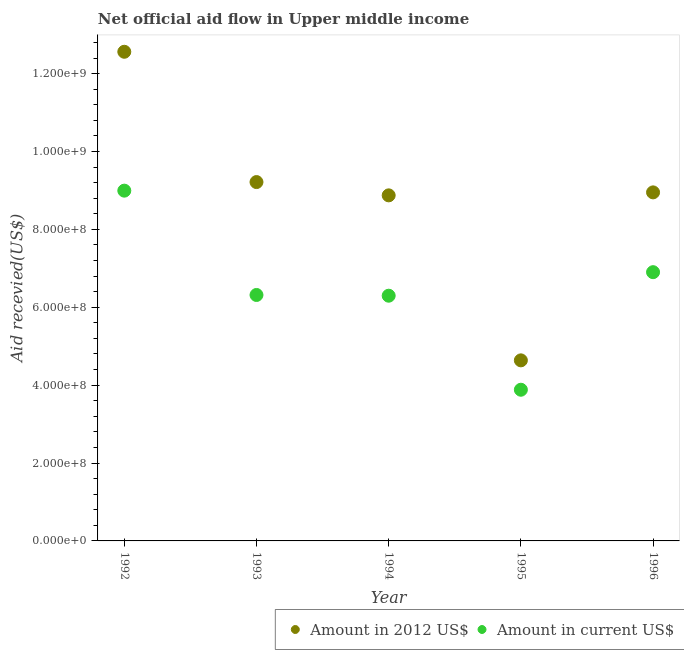What is the amount of aid received(expressed in 2012 us$) in 1995?
Offer a terse response. 4.64e+08. Across all years, what is the maximum amount of aid received(expressed in 2012 us$)?
Offer a very short reply. 1.26e+09. Across all years, what is the minimum amount of aid received(expressed in 2012 us$)?
Make the answer very short. 4.64e+08. In which year was the amount of aid received(expressed in 2012 us$) maximum?
Provide a short and direct response. 1992. In which year was the amount of aid received(expressed in us$) minimum?
Your answer should be compact. 1995. What is the total amount of aid received(expressed in us$) in the graph?
Ensure brevity in your answer.  3.24e+09. What is the difference between the amount of aid received(expressed in us$) in 1993 and that in 1995?
Keep it short and to the point. 2.43e+08. What is the difference between the amount of aid received(expressed in us$) in 1994 and the amount of aid received(expressed in 2012 us$) in 1996?
Provide a succinct answer. -2.65e+08. What is the average amount of aid received(expressed in 2012 us$) per year?
Your answer should be very brief. 8.85e+08. In the year 1996, what is the difference between the amount of aid received(expressed in 2012 us$) and amount of aid received(expressed in us$)?
Offer a very short reply. 2.05e+08. In how many years, is the amount of aid received(expressed in us$) greater than 880000000 US$?
Offer a very short reply. 1. What is the ratio of the amount of aid received(expressed in 2012 us$) in 1993 to that in 1995?
Make the answer very short. 1.99. Is the amount of aid received(expressed in us$) in 1994 less than that in 1995?
Keep it short and to the point. No. Is the difference between the amount of aid received(expressed in 2012 us$) in 1992 and 1994 greater than the difference between the amount of aid received(expressed in us$) in 1992 and 1994?
Offer a terse response. Yes. What is the difference between the highest and the second highest amount of aid received(expressed in 2012 us$)?
Give a very brief answer. 3.35e+08. What is the difference between the highest and the lowest amount of aid received(expressed in us$)?
Give a very brief answer. 5.11e+08. Is the sum of the amount of aid received(expressed in us$) in 1992 and 1993 greater than the maximum amount of aid received(expressed in 2012 us$) across all years?
Offer a very short reply. Yes. How many years are there in the graph?
Offer a very short reply. 5. Does the graph contain any zero values?
Offer a very short reply. No. Where does the legend appear in the graph?
Ensure brevity in your answer.  Bottom right. How many legend labels are there?
Keep it short and to the point. 2. How are the legend labels stacked?
Provide a succinct answer. Horizontal. What is the title of the graph?
Offer a very short reply. Net official aid flow in Upper middle income. Does "Automatic Teller Machines" appear as one of the legend labels in the graph?
Offer a terse response. No. What is the label or title of the Y-axis?
Ensure brevity in your answer.  Aid recevied(US$). What is the Aid recevied(US$) in Amount in 2012 US$ in 1992?
Provide a succinct answer. 1.26e+09. What is the Aid recevied(US$) of Amount in current US$ in 1992?
Provide a succinct answer. 8.99e+08. What is the Aid recevied(US$) in Amount in 2012 US$ in 1993?
Your answer should be very brief. 9.21e+08. What is the Aid recevied(US$) of Amount in current US$ in 1993?
Make the answer very short. 6.32e+08. What is the Aid recevied(US$) of Amount in 2012 US$ in 1994?
Your answer should be very brief. 8.87e+08. What is the Aid recevied(US$) of Amount in current US$ in 1994?
Make the answer very short. 6.30e+08. What is the Aid recevied(US$) in Amount in 2012 US$ in 1995?
Your answer should be compact. 4.64e+08. What is the Aid recevied(US$) of Amount in current US$ in 1995?
Keep it short and to the point. 3.88e+08. What is the Aid recevied(US$) in Amount in 2012 US$ in 1996?
Provide a short and direct response. 8.95e+08. What is the Aid recevied(US$) in Amount in current US$ in 1996?
Your answer should be very brief. 6.90e+08. Across all years, what is the maximum Aid recevied(US$) in Amount in 2012 US$?
Offer a very short reply. 1.26e+09. Across all years, what is the maximum Aid recevied(US$) in Amount in current US$?
Your response must be concise. 8.99e+08. Across all years, what is the minimum Aid recevied(US$) of Amount in 2012 US$?
Your answer should be very brief. 4.64e+08. Across all years, what is the minimum Aid recevied(US$) of Amount in current US$?
Make the answer very short. 3.88e+08. What is the total Aid recevied(US$) in Amount in 2012 US$ in the graph?
Make the answer very short. 4.42e+09. What is the total Aid recevied(US$) of Amount in current US$ in the graph?
Keep it short and to the point. 3.24e+09. What is the difference between the Aid recevied(US$) in Amount in 2012 US$ in 1992 and that in 1993?
Give a very brief answer. 3.35e+08. What is the difference between the Aid recevied(US$) in Amount in current US$ in 1992 and that in 1993?
Your answer should be very brief. 2.68e+08. What is the difference between the Aid recevied(US$) of Amount in 2012 US$ in 1992 and that in 1994?
Offer a very short reply. 3.69e+08. What is the difference between the Aid recevied(US$) in Amount in current US$ in 1992 and that in 1994?
Your answer should be very brief. 2.70e+08. What is the difference between the Aid recevied(US$) in Amount in 2012 US$ in 1992 and that in 1995?
Give a very brief answer. 7.92e+08. What is the difference between the Aid recevied(US$) in Amount in current US$ in 1992 and that in 1995?
Provide a short and direct response. 5.11e+08. What is the difference between the Aid recevied(US$) of Amount in 2012 US$ in 1992 and that in 1996?
Offer a terse response. 3.61e+08. What is the difference between the Aid recevied(US$) of Amount in current US$ in 1992 and that in 1996?
Keep it short and to the point. 2.09e+08. What is the difference between the Aid recevied(US$) of Amount in 2012 US$ in 1993 and that in 1994?
Give a very brief answer. 3.41e+07. What is the difference between the Aid recevied(US$) of Amount in current US$ in 1993 and that in 1994?
Your answer should be very brief. 1.90e+06. What is the difference between the Aid recevied(US$) in Amount in 2012 US$ in 1993 and that in 1995?
Keep it short and to the point. 4.58e+08. What is the difference between the Aid recevied(US$) of Amount in current US$ in 1993 and that in 1995?
Your response must be concise. 2.43e+08. What is the difference between the Aid recevied(US$) of Amount in 2012 US$ in 1993 and that in 1996?
Your response must be concise. 2.65e+07. What is the difference between the Aid recevied(US$) of Amount in current US$ in 1993 and that in 1996?
Offer a very short reply. -5.85e+07. What is the difference between the Aid recevied(US$) in Amount in 2012 US$ in 1994 and that in 1995?
Provide a short and direct response. 4.24e+08. What is the difference between the Aid recevied(US$) of Amount in current US$ in 1994 and that in 1995?
Offer a terse response. 2.41e+08. What is the difference between the Aid recevied(US$) in Amount in 2012 US$ in 1994 and that in 1996?
Make the answer very short. -7.65e+06. What is the difference between the Aid recevied(US$) in Amount in current US$ in 1994 and that in 1996?
Your response must be concise. -6.04e+07. What is the difference between the Aid recevied(US$) of Amount in 2012 US$ in 1995 and that in 1996?
Give a very brief answer. -4.31e+08. What is the difference between the Aid recevied(US$) of Amount in current US$ in 1995 and that in 1996?
Keep it short and to the point. -3.02e+08. What is the difference between the Aid recevied(US$) in Amount in 2012 US$ in 1992 and the Aid recevied(US$) in Amount in current US$ in 1993?
Offer a terse response. 6.24e+08. What is the difference between the Aid recevied(US$) of Amount in 2012 US$ in 1992 and the Aid recevied(US$) of Amount in current US$ in 1994?
Your answer should be compact. 6.26e+08. What is the difference between the Aid recevied(US$) of Amount in 2012 US$ in 1992 and the Aid recevied(US$) of Amount in current US$ in 1995?
Offer a terse response. 8.68e+08. What is the difference between the Aid recevied(US$) in Amount in 2012 US$ in 1992 and the Aid recevied(US$) in Amount in current US$ in 1996?
Offer a terse response. 5.66e+08. What is the difference between the Aid recevied(US$) of Amount in 2012 US$ in 1993 and the Aid recevied(US$) of Amount in current US$ in 1994?
Keep it short and to the point. 2.92e+08. What is the difference between the Aid recevied(US$) in Amount in 2012 US$ in 1993 and the Aid recevied(US$) in Amount in current US$ in 1995?
Your response must be concise. 5.33e+08. What is the difference between the Aid recevied(US$) of Amount in 2012 US$ in 1993 and the Aid recevied(US$) of Amount in current US$ in 1996?
Your response must be concise. 2.31e+08. What is the difference between the Aid recevied(US$) of Amount in 2012 US$ in 1994 and the Aid recevied(US$) of Amount in current US$ in 1995?
Offer a very short reply. 4.99e+08. What is the difference between the Aid recevied(US$) of Amount in 2012 US$ in 1994 and the Aid recevied(US$) of Amount in current US$ in 1996?
Offer a very short reply. 1.97e+08. What is the difference between the Aid recevied(US$) in Amount in 2012 US$ in 1995 and the Aid recevied(US$) in Amount in current US$ in 1996?
Keep it short and to the point. -2.26e+08. What is the average Aid recevied(US$) in Amount in 2012 US$ per year?
Offer a very short reply. 8.85e+08. What is the average Aid recevied(US$) of Amount in current US$ per year?
Provide a succinct answer. 6.48e+08. In the year 1992, what is the difference between the Aid recevied(US$) in Amount in 2012 US$ and Aid recevied(US$) in Amount in current US$?
Ensure brevity in your answer.  3.57e+08. In the year 1993, what is the difference between the Aid recevied(US$) in Amount in 2012 US$ and Aid recevied(US$) in Amount in current US$?
Make the answer very short. 2.90e+08. In the year 1994, what is the difference between the Aid recevied(US$) of Amount in 2012 US$ and Aid recevied(US$) of Amount in current US$?
Your answer should be compact. 2.58e+08. In the year 1995, what is the difference between the Aid recevied(US$) in Amount in 2012 US$ and Aid recevied(US$) in Amount in current US$?
Your answer should be very brief. 7.54e+07. In the year 1996, what is the difference between the Aid recevied(US$) of Amount in 2012 US$ and Aid recevied(US$) of Amount in current US$?
Your answer should be compact. 2.05e+08. What is the ratio of the Aid recevied(US$) of Amount in 2012 US$ in 1992 to that in 1993?
Give a very brief answer. 1.36. What is the ratio of the Aid recevied(US$) of Amount in current US$ in 1992 to that in 1993?
Keep it short and to the point. 1.42. What is the ratio of the Aid recevied(US$) of Amount in 2012 US$ in 1992 to that in 1994?
Your answer should be compact. 1.42. What is the ratio of the Aid recevied(US$) of Amount in current US$ in 1992 to that in 1994?
Your response must be concise. 1.43. What is the ratio of the Aid recevied(US$) in Amount in 2012 US$ in 1992 to that in 1995?
Make the answer very short. 2.71. What is the ratio of the Aid recevied(US$) in Amount in current US$ in 1992 to that in 1995?
Keep it short and to the point. 2.32. What is the ratio of the Aid recevied(US$) of Amount in 2012 US$ in 1992 to that in 1996?
Provide a short and direct response. 1.4. What is the ratio of the Aid recevied(US$) of Amount in current US$ in 1992 to that in 1996?
Make the answer very short. 1.3. What is the ratio of the Aid recevied(US$) in Amount in 2012 US$ in 1993 to that in 1994?
Provide a succinct answer. 1.04. What is the ratio of the Aid recevied(US$) of Amount in 2012 US$ in 1993 to that in 1995?
Your answer should be compact. 1.99. What is the ratio of the Aid recevied(US$) in Amount in current US$ in 1993 to that in 1995?
Give a very brief answer. 1.63. What is the ratio of the Aid recevied(US$) in Amount in 2012 US$ in 1993 to that in 1996?
Keep it short and to the point. 1.03. What is the ratio of the Aid recevied(US$) in Amount in current US$ in 1993 to that in 1996?
Offer a very short reply. 0.92. What is the ratio of the Aid recevied(US$) in Amount in 2012 US$ in 1994 to that in 1995?
Your answer should be very brief. 1.91. What is the ratio of the Aid recevied(US$) in Amount in current US$ in 1994 to that in 1995?
Make the answer very short. 1.62. What is the ratio of the Aid recevied(US$) of Amount in current US$ in 1994 to that in 1996?
Ensure brevity in your answer.  0.91. What is the ratio of the Aid recevied(US$) of Amount in 2012 US$ in 1995 to that in 1996?
Offer a terse response. 0.52. What is the ratio of the Aid recevied(US$) of Amount in current US$ in 1995 to that in 1996?
Provide a succinct answer. 0.56. What is the difference between the highest and the second highest Aid recevied(US$) of Amount in 2012 US$?
Make the answer very short. 3.35e+08. What is the difference between the highest and the second highest Aid recevied(US$) in Amount in current US$?
Your answer should be compact. 2.09e+08. What is the difference between the highest and the lowest Aid recevied(US$) of Amount in 2012 US$?
Your response must be concise. 7.92e+08. What is the difference between the highest and the lowest Aid recevied(US$) in Amount in current US$?
Keep it short and to the point. 5.11e+08. 